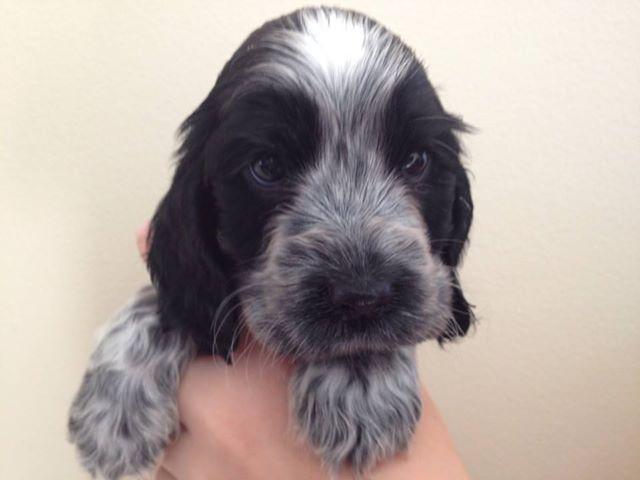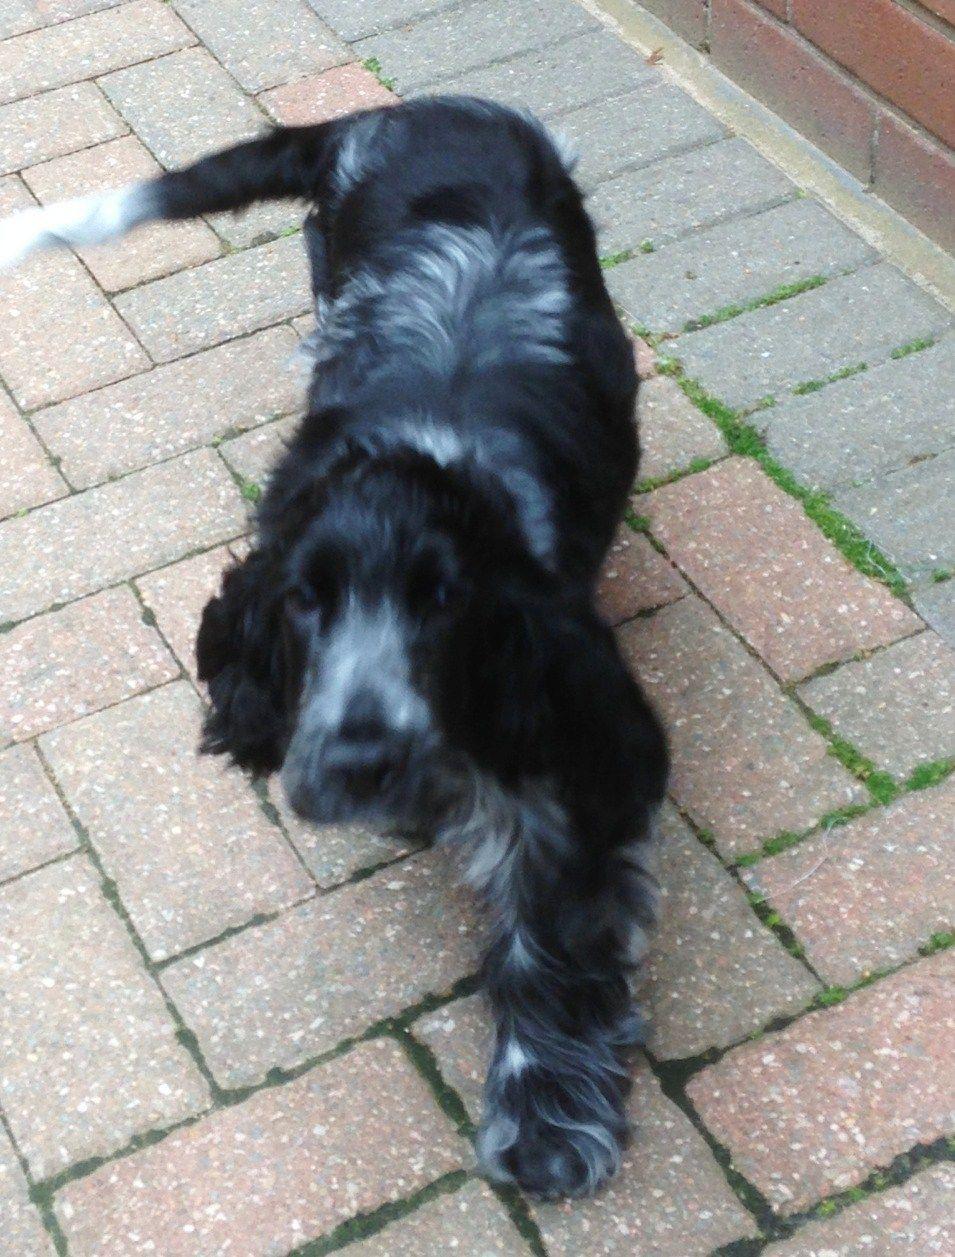The first image is the image on the left, the second image is the image on the right. Assess this claim about the two images: "Someone is holding up the dog in the image on the right.". Correct or not? Answer yes or no. No. The first image is the image on the left, the second image is the image on the right. Analyze the images presented: Is the assertion "The pair of images includes two dogs held by human hands." valid? Answer yes or no. No. 